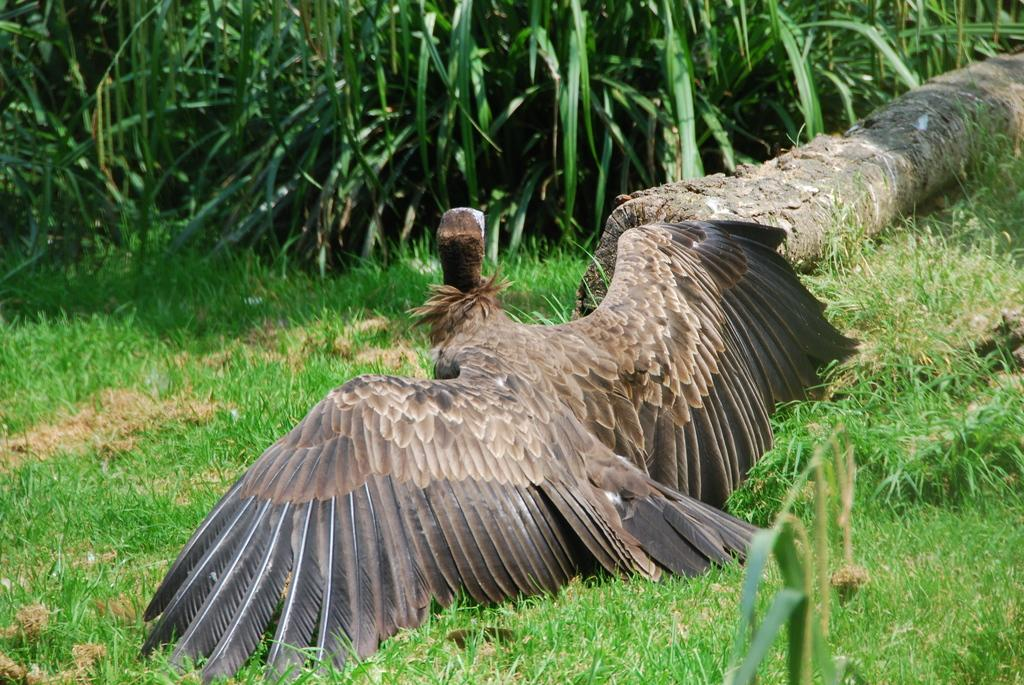What type of animal can be seen in the image? There is a bird in the image. What is present on the ground in the image? There is tree bark on the ground in the image. What can be seen in the background of the image? There are plants visible in the background of the image. What game is the bird playing in the image? There is no game being played in the image; it simply shows a bird and other natural elements. 